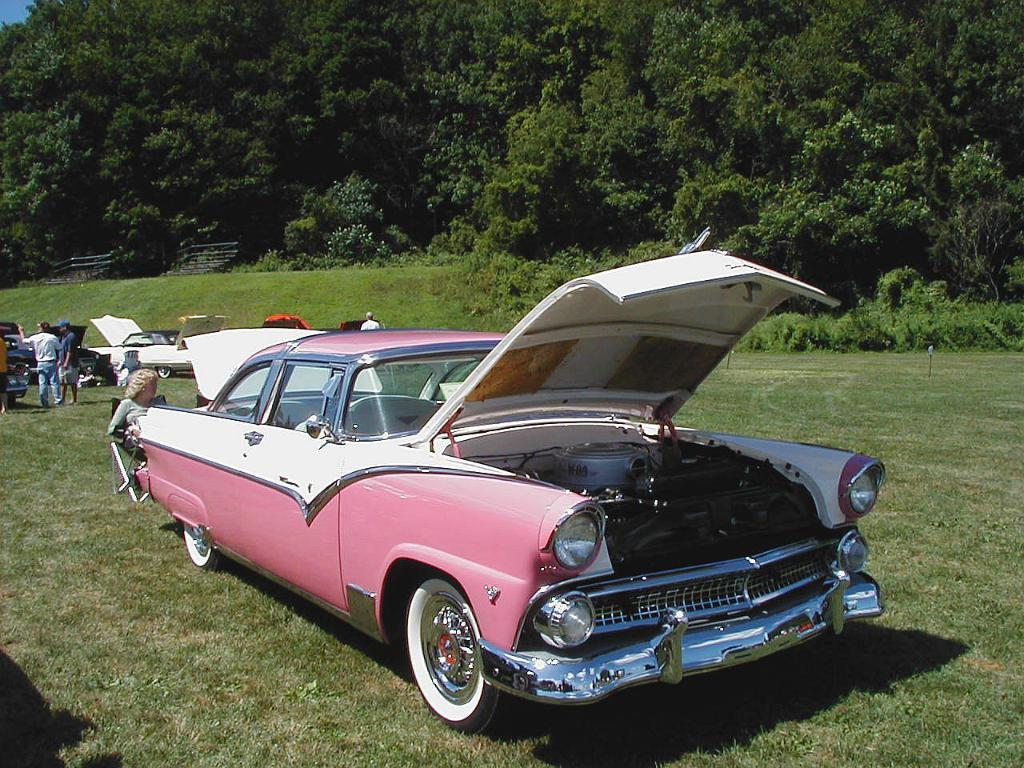What types of objects are present in the image? There are vehicles and people in the image. Can you describe the woman in the image? There is a woman sitting on a chair on the left side of the image. What can be seen in the background of the image? There are trees visible in the background of the image. What type of stamp can be seen on the woman's forehead in the image? There is no stamp visible on the woman's forehead in the image. What material is the plastic chair made of that the woman is sitting on? The facts do not mention the material of the chair, only that the woman is sitting on a chair. 